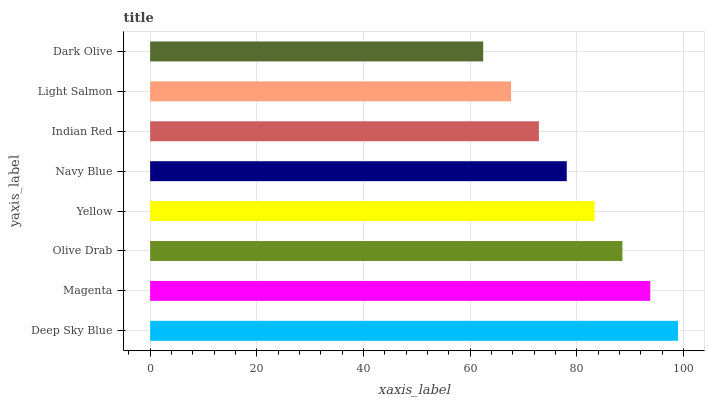Is Dark Olive the minimum?
Answer yes or no. Yes. Is Deep Sky Blue the maximum?
Answer yes or no. Yes. Is Magenta the minimum?
Answer yes or no. No. Is Magenta the maximum?
Answer yes or no. No. Is Deep Sky Blue greater than Magenta?
Answer yes or no. Yes. Is Magenta less than Deep Sky Blue?
Answer yes or no. Yes. Is Magenta greater than Deep Sky Blue?
Answer yes or no. No. Is Deep Sky Blue less than Magenta?
Answer yes or no. No. Is Yellow the high median?
Answer yes or no. Yes. Is Navy Blue the low median?
Answer yes or no. Yes. Is Dark Olive the high median?
Answer yes or no. No. Is Dark Olive the low median?
Answer yes or no. No. 